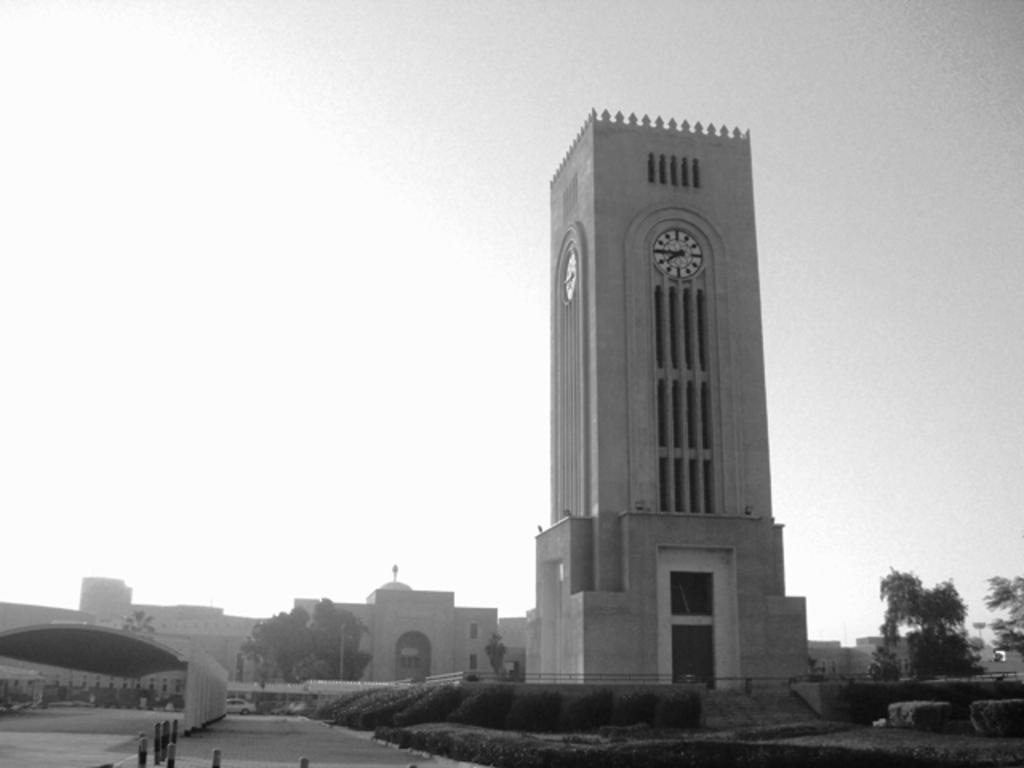What type of structures can be seen in the image? There are buildings in the image. What else can be found in the image besides buildings? There are trees, a shed, and poles in the image. What is visible in the background of the image? The sky is visible in the image. Are there any time-related features in the image? Yes, there are clocks on the buildings. What type of anger can be seen on the stove in the image? There is no stove present in the image, and therefore no anger can be observed. What is the middle item in the image? It is not possible to determine a "middle" item in the image without more specific information about the arrangement of objects. 